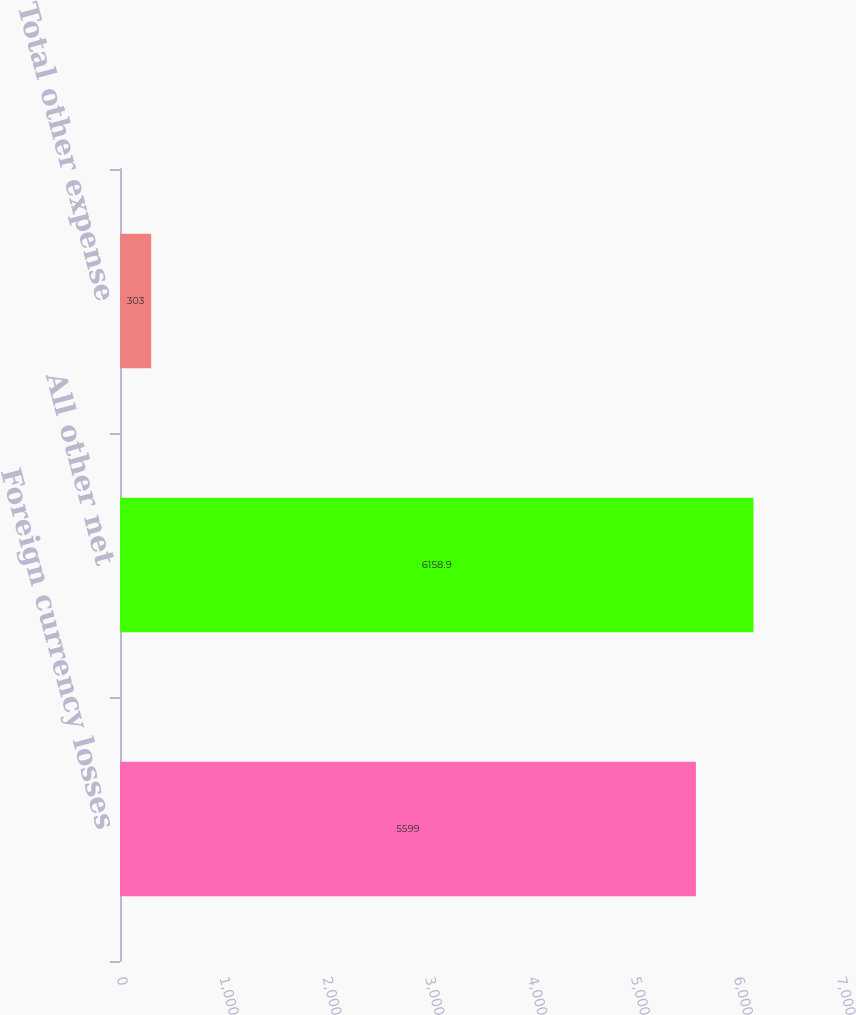Convert chart to OTSL. <chart><loc_0><loc_0><loc_500><loc_500><bar_chart><fcel>Foreign currency losses<fcel>All other net<fcel>Total other expense<nl><fcel>5599<fcel>6158.9<fcel>303<nl></chart> 